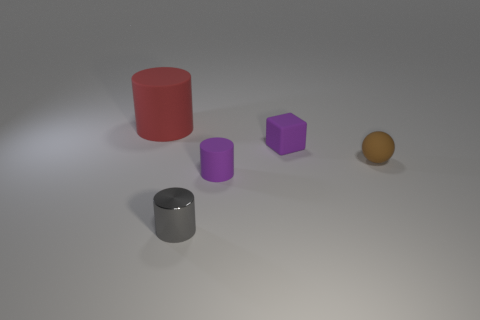Add 3 cyan shiny cylinders. How many objects exist? 8 Subtract all cylinders. How many objects are left? 2 Add 5 rubber blocks. How many rubber blocks exist? 6 Subtract 0 gray blocks. How many objects are left? 5 Subtract all big red things. Subtract all big objects. How many objects are left? 3 Add 2 purple blocks. How many purple blocks are left? 3 